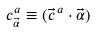Convert formula to latex. <formula><loc_0><loc_0><loc_500><loc_500>c ^ { a } _ { \vec { \alpha } } \equiv ( { \vec { c } } ^ { \, a } \cdot { \vec { \alpha } } )</formula> 